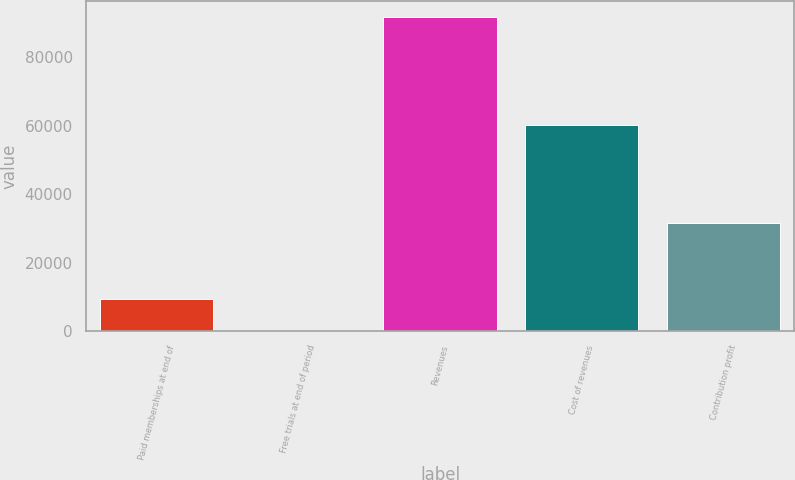<chart> <loc_0><loc_0><loc_500><loc_500><bar_chart><fcel>Paid memberships at end of<fcel>Free trials at end of period<fcel>Revenues<fcel>Cost of revenues<fcel>Contribution profit<nl><fcel>9205.8<fcel>32<fcel>91770<fcel>60217<fcel>31553<nl></chart> 